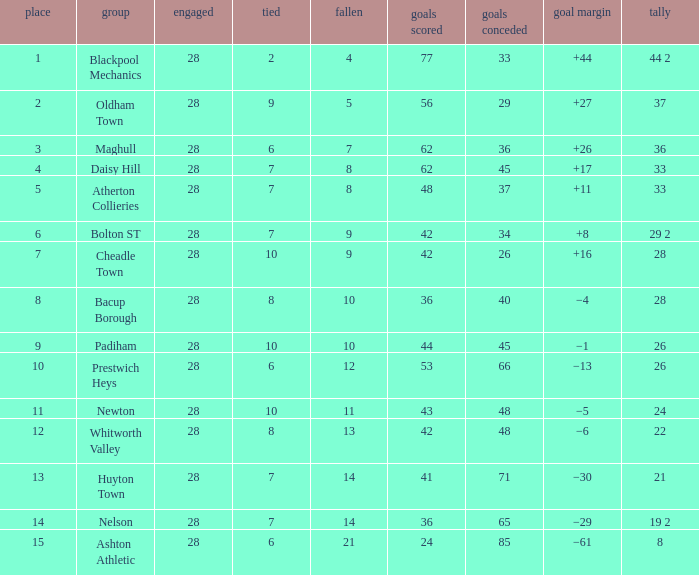For entries with lost larger than 21 and goals for smaller than 36, what is the average drawn? None. 